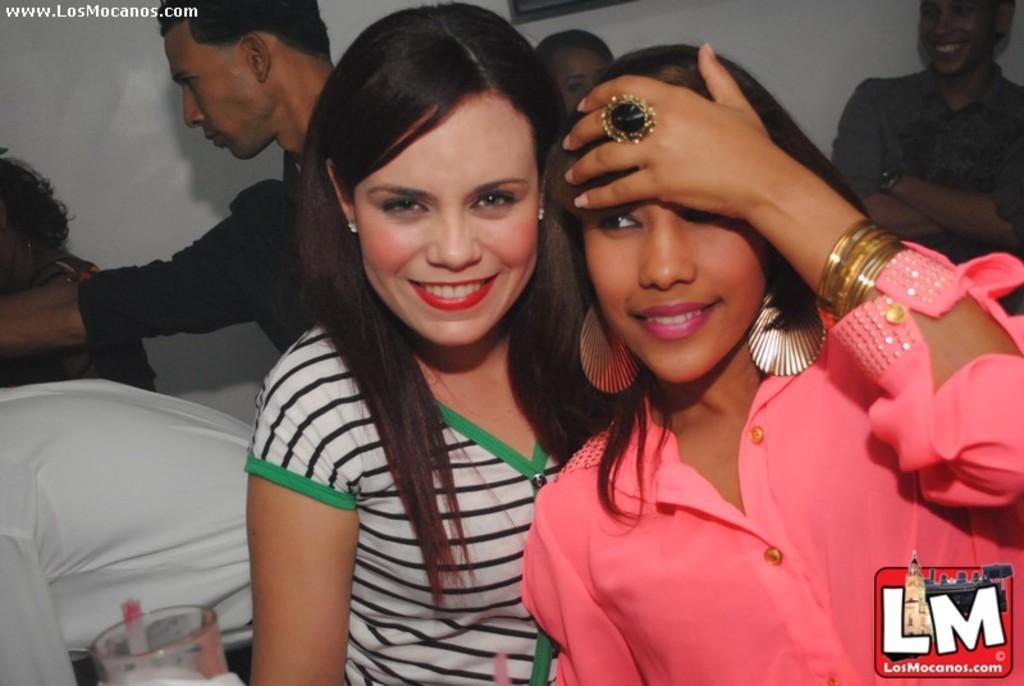Could you give a brief overview of what you see in this image? Here we can see few persons and they are smiling. Here we can see a glass and a logo. In the background there is a wall. 